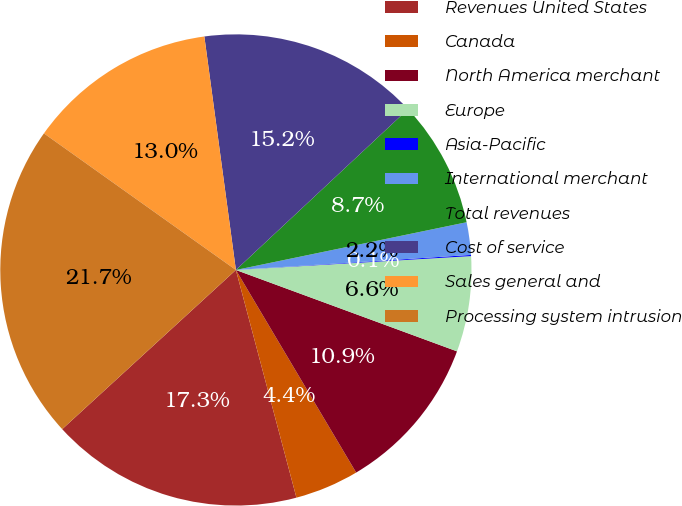Convert chart. <chart><loc_0><loc_0><loc_500><loc_500><pie_chart><fcel>Revenues United States<fcel>Canada<fcel>North America merchant<fcel>Europe<fcel>Asia-Pacific<fcel>International merchant<fcel>Total revenues<fcel>Cost of service<fcel>Sales general and<fcel>Processing system intrusion<nl><fcel>17.33%<fcel>4.39%<fcel>10.86%<fcel>6.55%<fcel>0.08%<fcel>2.23%<fcel>8.71%<fcel>15.18%<fcel>13.02%<fcel>21.65%<nl></chart> 